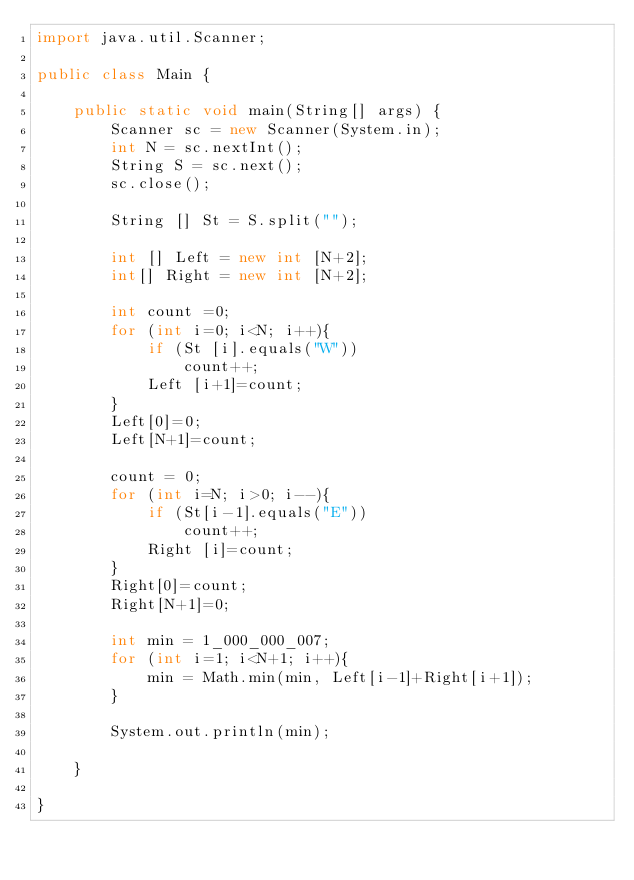<code> <loc_0><loc_0><loc_500><loc_500><_Java_>import java.util.Scanner;

public class Main {

	public static void main(String[] args) {
		Scanner sc = new Scanner(System.in);
		int N = sc.nextInt();
		String S = sc.next();
		sc.close();
		
		String [] St = S.split("");
		
		int [] Left = new int [N+2];
		int[] Right = new int [N+2];
		
		int count =0;
		for (int i=0; i<N; i++){
			if (St [i].equals("W"))
				count++;
			Left [i+1]=count;
		}
		Left[0]=0;
		Left[N+1]=count;
		
		count = 0;
		for (int i=N; i>0; i--){
			if (St[i-1].equals("E"))
				count++;
			Right [i]=count;
		}
		Right[0]=count;
		Right[N+1]=0;
		
		int min = 1_000_000_007;
		for (int i=1; i<N+1; i++){
			min = Math.min(min, Left[i-1]+Right[i+1]);
		}
	
		System.out.println(min);

	}

}</code> 